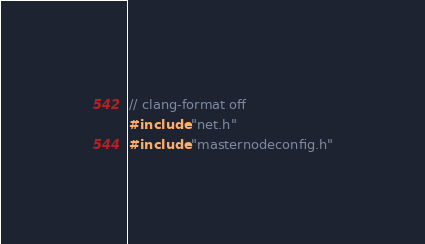<code> <loc_0><loc_0><loc_500><loc_500><_C++_>// clang-format off
#include "net.h"
#include "masternodeconfig.h"</code> 